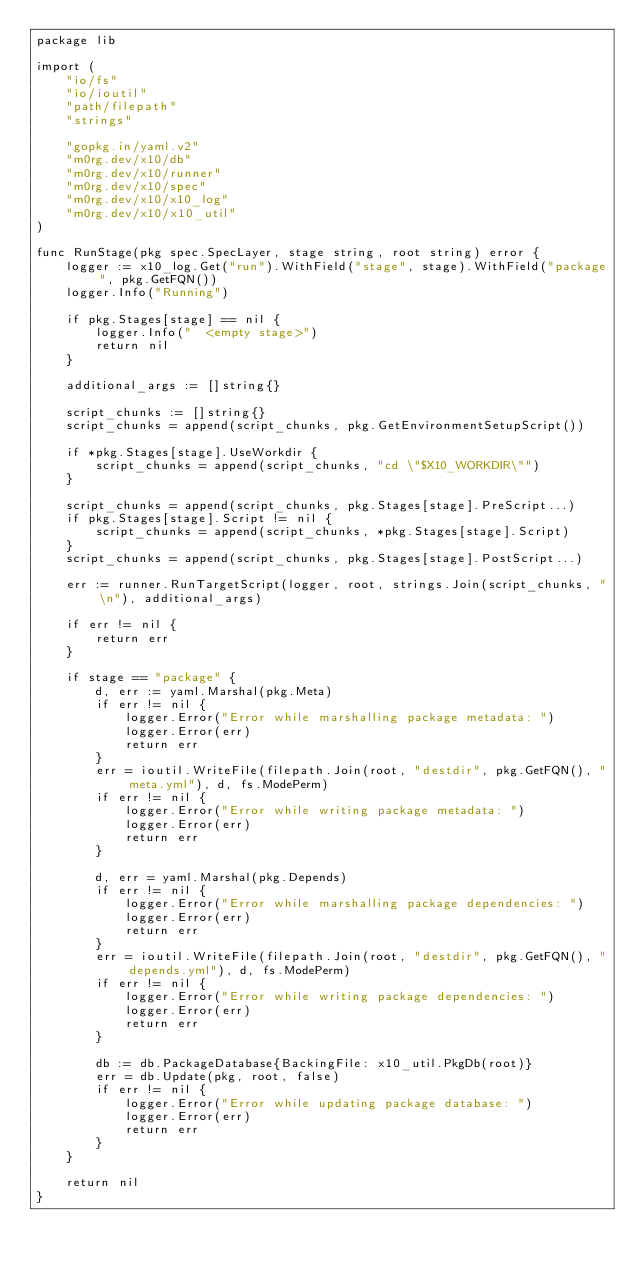<code> <loc_0><loc_0><loc_500><loc_500><_Go_>package lib

import (
	"io/fs"
	"io/ioutil"
	"path/filepath"
	"strings"

	"gopkg.in/yaml.v2"
	"m0rg.dev/x10/db"
	"m0rg.dev/x10/runner"
	"m0rg.dev/x10/spec"
	"m0rg.dev/x10/x10_log"
	"m0rg.dev/x10/x10_util"
)

func RunStage(pkg spec.SpecLayer, stage string, root string) error {
	logger := x10_log.Get("run").WithField("stage", stage).WithField("package", pkg.GetFQN())
	logger.Info("Running")

	if pkg.Stages[stage] == nil {
		logger.Info("  <empty stage>")
		return nil
	}

	additional_args := []string{}

	script_chunks := []string{}
	script_chunks = append(script_chunks, pkg.GetEnvironmentSetupScript())

	if *pkg.Stages[stage].UseWorkdir {
		script_chunks = append(script_chunks, "cd \"$X10_WORKDIR\"")
	}

	script_chunks = append(script_chunks, pkg.Stages[stage].PreScript...)
	if pkg.Stages[stage].Script != nil {
		script_chunks = append(script_chunks, *pkg.Stages[stage].Script)
	}
	script_chunks = append(script_chunks, pkg.Stages[stage].PostScript...)

	err := runner.RunTargetScript(logger, root, strings.Join(script_chunks, "\n"), additional_args)

	if err != nil {
		return err
	}

	if stage == "package" {
		d, err := yaml.Marshal(pkg.Meta)
		if err != nil {
			logger.Error("Error while marshalling package metadata: ")
			logger.Error(err)
			return err
		}
		err = ioutil.WriteFile(filepath.Join(root, "destdir", pkg.GetFQN(), "meta.yml"), d, fs.ModePerm)
		if err != nil {
			logger.Error("Error while writing package metadata: ")
			logger.Error(err)
			return err
		}

		d, err = yaml.Marshal(pkg.Depends)
		if err != nil {
			logger.Error("Error while marshalling package dependencies: ")
			logger.Error(err)
			return err
		}
		err = ioutil.WriteFile(filepath.Join(root, "destdir", pkg.GetFQN(), "depends.yml"), d, fs.ModePerm)
		if err != nil {
			logger.Error("Error while writing package dependencies: ")
			logger.Error(err)
			return err
		}

		db := db.PackageDatabase{BackingFile: x10_util.PkgDb(root)}
		err = db.Update(pkg, root, false)
		if err != nil {
			logger.Error("Error while updating package database: ")
			logger.Error(err)
			return err
		}
	}

	return nil
}
</code> 